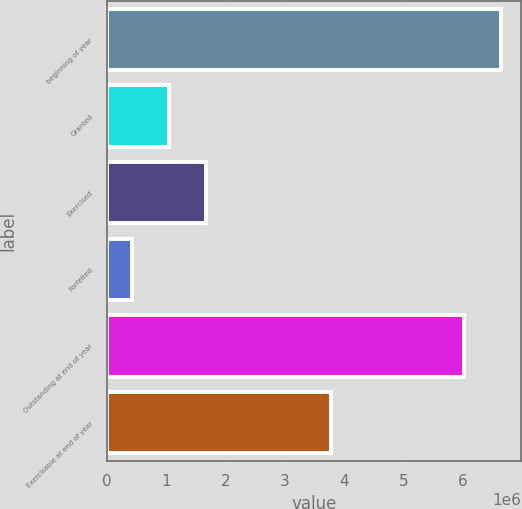Convert chart. <chart><loc_0><loc_0><loc_500><loc_500><bar_chart><fcel>beginning of year<fcel>Granted<fcel>Exercised<fcel>Forfeited<fcel>Outstanding at end of year<fcel>Exercisable at end of year<nl><fcel>6.64764e+06<fcel>1.03811e+06<fcel>1.6613e+06<fcel>414932<fcel>6.02446e+06<fcel>3.77563e+06<nl></chart> 